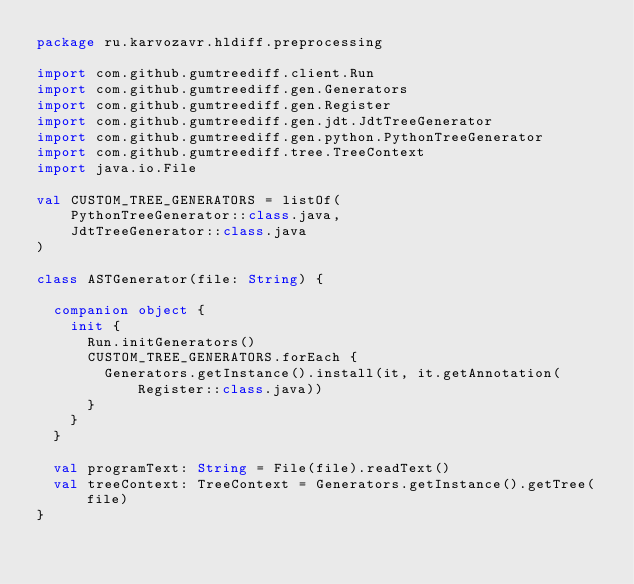<code> <loc_0><loc_0><loc_500><loc_500><_Kotlin_>package ru.karvozavr.hldiff.preprocessing

import com.github.gumtreediff.client.Run
import com.github.gumtreediff.gen.Generators
import com.github.gumtreediff.gen.Register
import com.github.gumtreediff.gen.jdt.JdtTreeGenerator
import com.github.gumtreediff.gen.python.PythonTreeGenerator
import com.github.gumtreediff.tree.TreeContext
import java.io.File

val CUSTOM_TREE_GENERATORS = listOf(
    PythonTreeGenerator::class.java,
    JdtTreeGenerator::class.java
)

class ASTGenerator(file: String) {

  companion object {
    init {
      Run.initGenerators()
      CUSTOM_TREE_GENERATORS.forEach {
        Generators.getInstance().install(it, it.getAnnotation(Register::class.java))
      }
    }
  }

  val programText: String = File(file).readText()
  val treeContext: TreeContext = Generators.getInstance().getTree(file)
}
</code> 